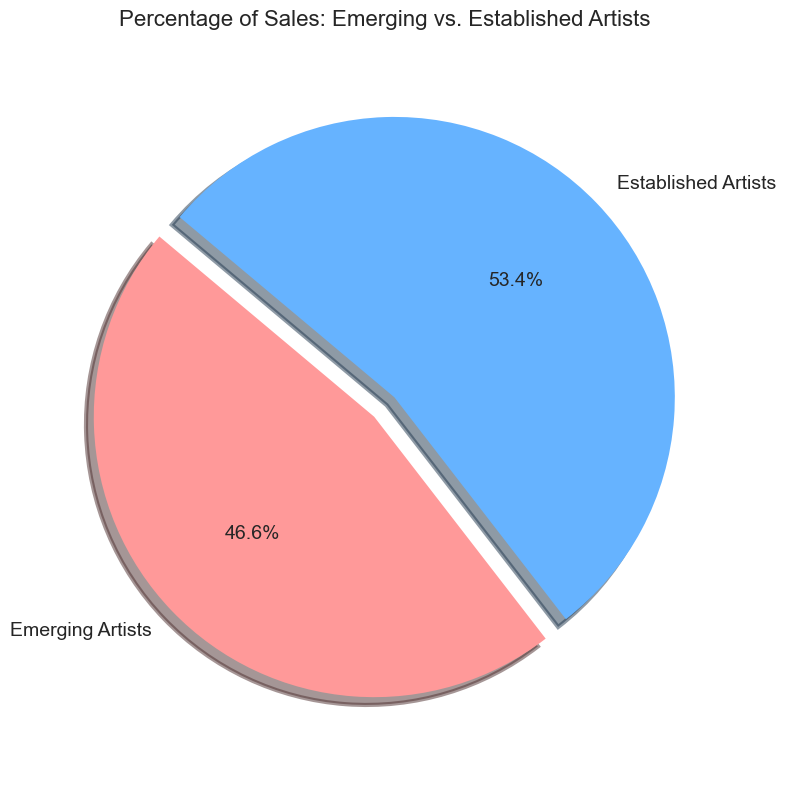What's the percentage of sales from emerging artists? The pie chart shows the percentage of sales from both emerging and established artists, and the label for emerging artists indicates their percentage.
Answer: 47.7% What's the difference in the percentage of sales between emerging and established artists? To find the difference, subtract the percentage of established artists from that of emerging artists. Established artists have 100% - 47.7% = 52.3%. Therefore, the difference is 52.3% - 47.7% = 4.6%.
Answer: 4.6% What color represents emerging artists in the pie chart? From the visual attributes of the pie chart, the segment representing emerging artists is shaded in light red.
Answer: Light red What proportion of the pie does the sales of established artists occupy? The pie chart shows that established artists account for 52.3% of the sales, which is just over half of the pie.
Answer: 52.3% Is the percentage of sales from emerging artists greater than that from established artists? The pie chart indicates that the percentage of sales from emerging artists is 47.7%, which is less than the percentage from established artists, which is 52.3%.
Answer: No If the total art sales were $1 million, how much would be attributed to emerging artists and established artists? Calculate 47.7% of $1 million for emerging artists, which is 0.477 * 1,000,000 = $477,000. For established artists, it’s 52.3% of $1 million, which is 0.523 * 1,000,000 = $523,000.
Answer: Emerging: $477,000, Established: $523,000 What is the angle of the sector representing established artists? A full circle is 360 degrees. Since established artists occupy 52.3% of the pie, calculate 52.3% of 360, which is 0.523 * 360 = 188.28 degrees.
Answer: 188.28 degrees If there was a 10% increase in the sales percentage of emerging artists, what would be the new percentages for both groups? An increase of 10% in emerging artists' sales would change their percentage to 47.7% + 10% = 57.7%. Consequently, established artists' percentage would be 100% - 57.7% = 42.3%.
Answer: Emerging: 57.7%, Established: 42.3% 